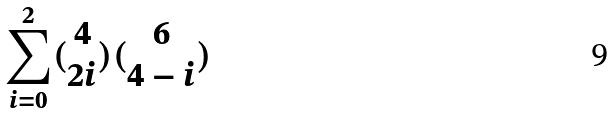Convert formula to latex. <formula><loc_0><loc_0><loc_500><loc_500>\sum _ { i = 0 } ^ { 2 } ( \begin{matrix} 4 \\ 2 i \end{matrix} ) ( \begin{matrix} 6 \\ 4 - i \end{matrix} )</formula> 